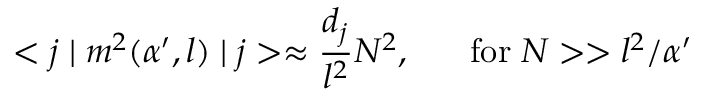<formula> <loc_0><loc_0><loc_500><loc_500>< j | m ^ { 2 } ( \alpha ^ { \prime } , l ) | j > \approx \frac { d _ { j } } { l ^ { 2 } } N ^ { 2 } , \, f o r \, N > > l ^ { 2 } / \alpha ^ { \prime }</formula> 